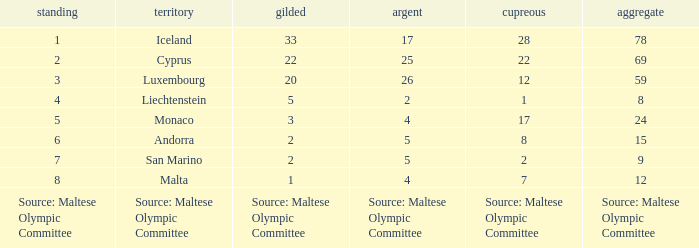What is the total medal count for the nation that has 5 gold? 8.0. 